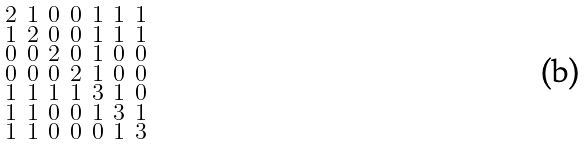Convert formula to latex. <formula><loc_0><loc_0><loc_500><loc_500>\begin{smallmatrix} 2 & 1 & 0 & 0 & 1 & 1 & 1 \\ 1 & 2 & 0 & 0 & 1 & 1 & 1 \\ 0 & 0 & 2 & 0 & 1 & 0 & 0 \\ 0 & 0 & 0 & 2 & 1 & 0 & 0 \\ 1 & 1 & 1 & 1 & 3 & 1 & 0 \\ 1 & 1 & 0 & 0 & 1 & 3 & 1 \\ 1 & 1 & 0 & 0 & 0 & 1 & 3 \end{smallmatrix}</formula> 